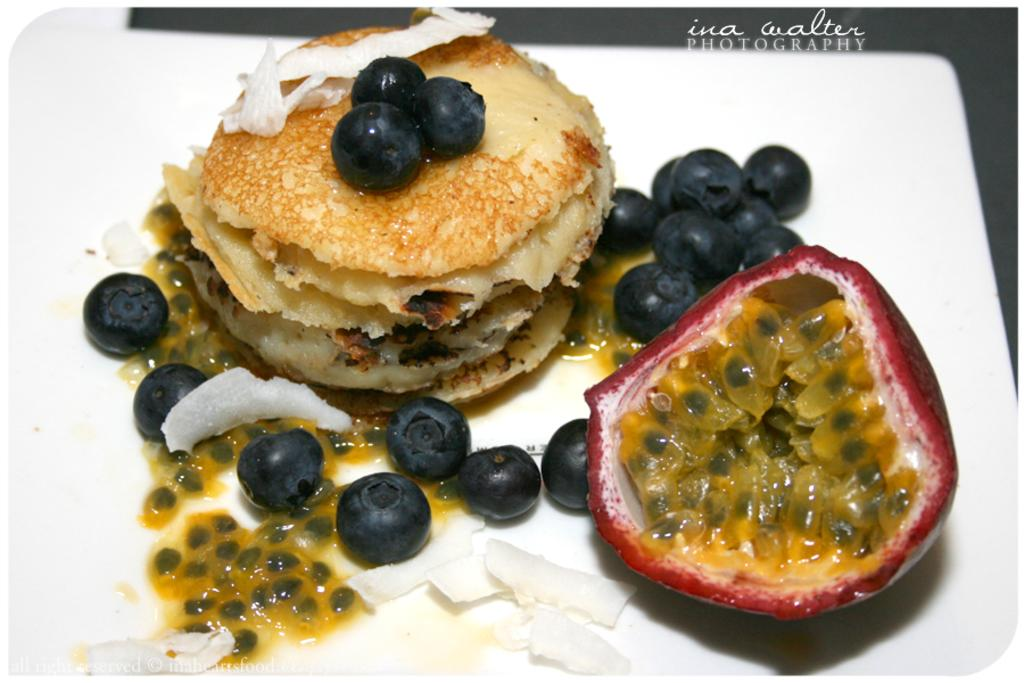What type of fruit can be seen in the image? There are grapes and a pomegranate in the image. What else is present on the plate in the image? There is a baked item on a plate in the image. What type of suit is the fork wearing in the image? There is no suit or fork present in the image. 